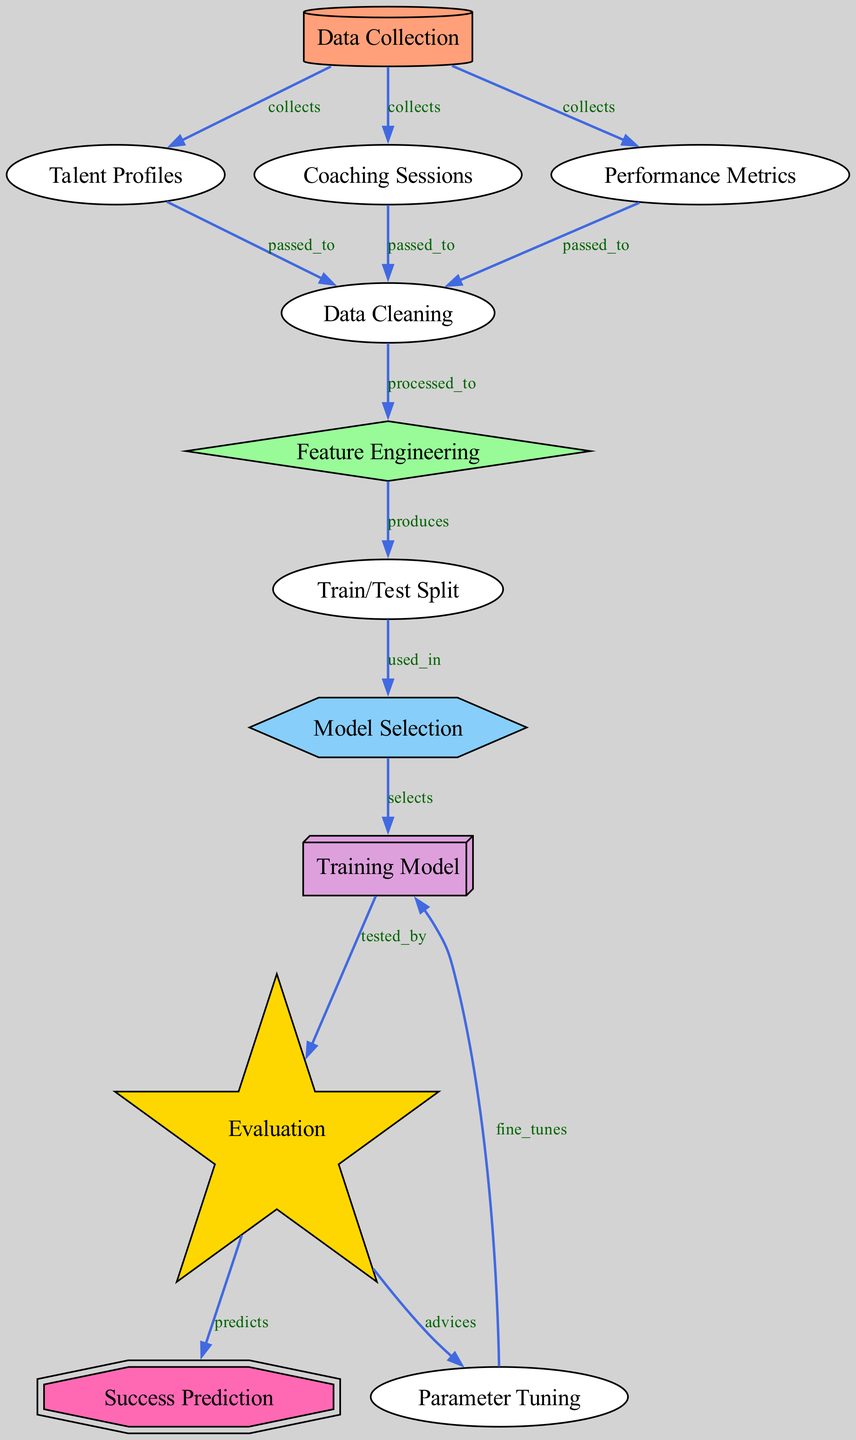What is the first step in the diagram? The first node in the diagram is "Data Collection," which initiates the flow of information. It is represented without any incoming edges.
Answer: Data Collection How many nodes are present in the diagram? By counting the nodes listed in the data, there are 12 distinct nodes present in the diagram.
Answer: 12 What relationship exists between "Coaching Sessions" and "Data Cleaning"? According to the edge, "Coaching Sessions" passes its data to "Data Cleaning," meaning it contributes to the cleaning process in this flow.
Answer: passed_to Which node is responsible for success prediction? The final result of the diagram indicates that the "Success Prediction" node is where success rates are predicted based on previous evaluations.
Answer: Success Prediction What is the purpose of the "Train/Test Split" node? The "Train/Test Split" node is used in preparing the data for model selection, creating distinct datasets for training and testing.
Answer: used_in How does "Evaluation" connect to "Parameter Tuning"? The "Evaluation" node provides advice to "Parameter Tuning," suggesting adjustments based on its assessments.
Answer: advices What process comes after "Feature Engineering"? The process that follows "Feature Engineering" is the "Train/Test Split," indicating that features are partitioned into train and test sets.
Answer: produces How does "Training Model" relate to "Evaluation"? The "Training Model" is tested by the "Evaluation," showing that the model's performance is analyzed at this stage.
Answer: tested_by What influenced the selection of the model? The edge shows that the "Model Selection" node is where a suitable model is chosen based on the preceding train/test split.
Answer: selects 